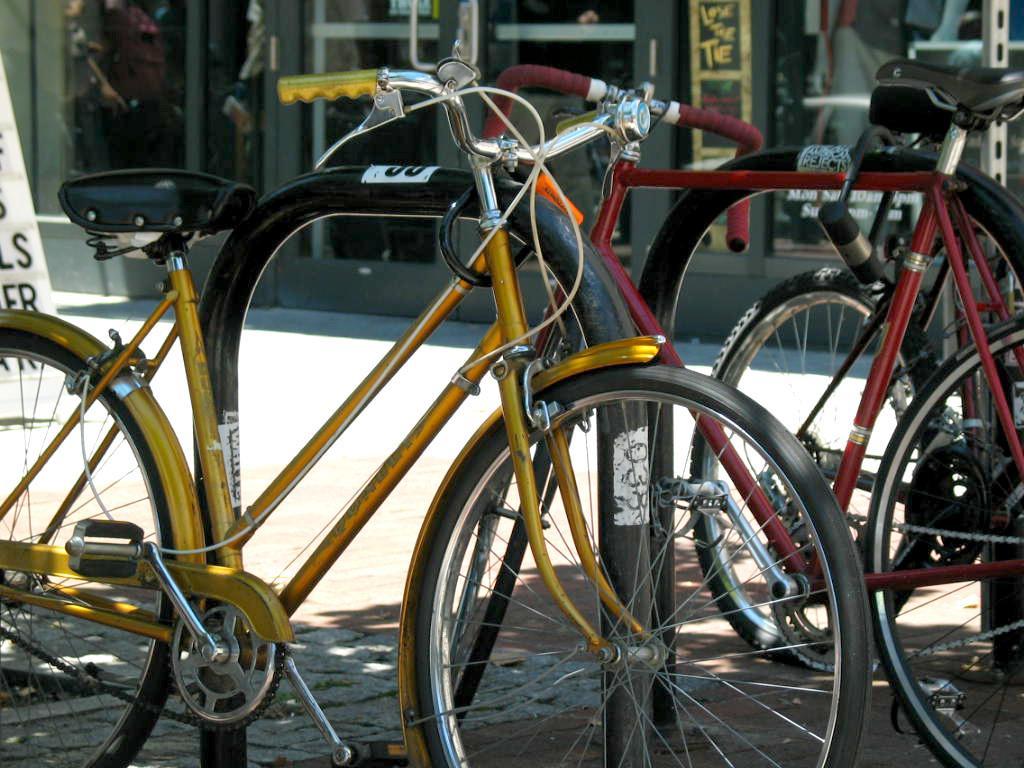Describe this image in one or two sentences. This picture might be taken outside of the building and it is sunny. In this image, in the middle, we can see few bicycles. On the left side, we can see hoardings. In the background, we can see a building, we can also see a glass door, at the bottom there is a road. 